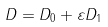<formula> <loc_0><loc_0><loc_500><loc_500>D = D _ { 0 } + \varepsilon D _ { 1 }</formula> 